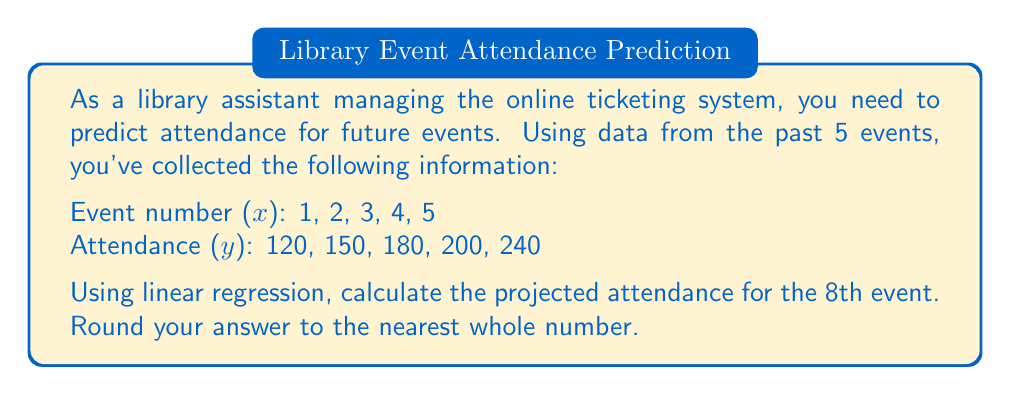Provide a solution to this math problem. To solve this problem using linear regression, we'll follow these steps:

1) First, we need to calculate the following sums:
   $\sum x$, $\sum y$, $\sum x^2$, $\sum xy$, and $n$ (number of data points)

   $\sum x = 1 + 2 + 3 + 4 + 5 = 15$
   $\sum y = 120 + 150 + 180 + 200 + 240 = 890$
   $\sum x^2 = 1^2 + 2^2 + 3^2 + 4^2 + 5^2 = 55$
   $\sum xy = (1 \times 120) + (2 \times 150) + (3 \times 180) + (4 \times 200) + (5 \times 240) = 2970$
   $n = 5$

2) Now, we can use these sums to calculate the slope (m) and y-intercept (b) of the regression line:

   $m = \frac{n\sum xy - \sum x \sum y}{n\sum x^2 - (\sum x)^2}$

   $m = \frac{5(2970) - 15(890)}{5(55) - 15^2} = \frac{14850 - 13350}{275 - 225} = \frac{1500}{50} = 30$

   $b = \frac{\sum y - m\sum x}{n}$

   $b = \frac{890 - 30(15)}{5} = \frac{890 - 450}{5} = \frac{440}{5} = 88$

3) The equation of the regression line is:
   $y = mx + b = 30x + 88$

4) To predict the attendance for the 8th event, we substitute $x = 8$ into this equation:

   $y = 30(8) + 88 = 240 + 88 = 328$

5) Rounding to the nearest whole number: 328
Answer: 328 attendees 